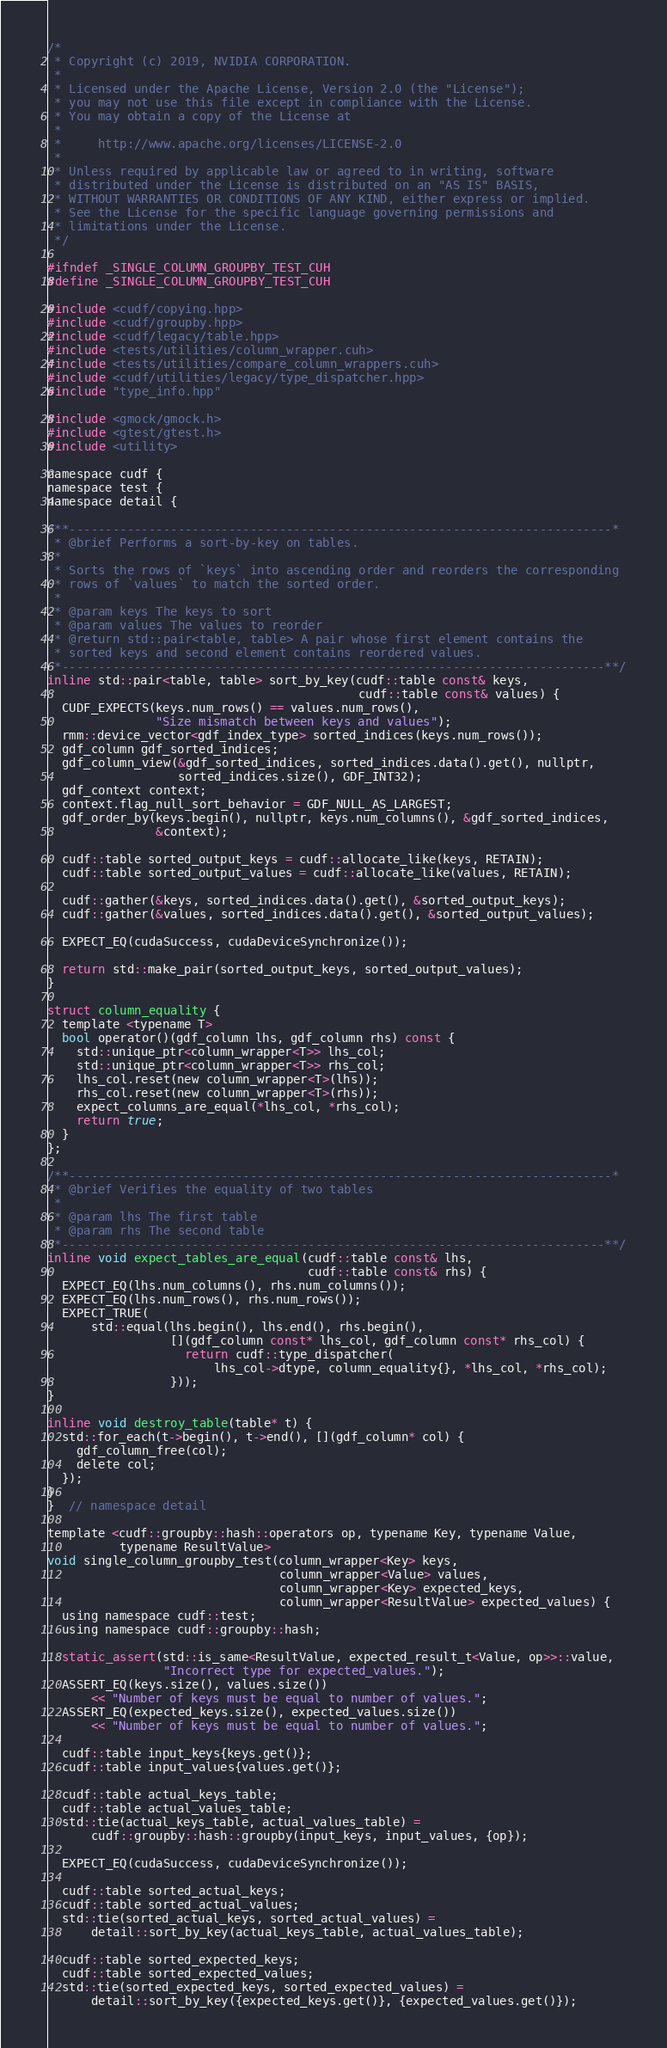Convert code to text. <code><loc_0><loc_0><loc_500><loc_500><_Cuda_>/*
 * Copyright (c) 2019, NVIDIA CORPORATION.
 *
 * Licensed under the Apache License, Version 2.0 (the "License");
 * you may not use this file except in compliance with the License.
 * You may obtain a copy of the License at
 *
 *     http://www.apache.org/licenses/LICENSE-2.0
 *
 * Unless required by applicable law or agreed to in writing, software
 * distributed under the License is distributed on an "AS IS" BASIS,
 * WITHOUT WARRANTIES OR CONDITIONS OF ANY KIND, either express or implied.
 * See the License for the specific language governing permissions and
 * limitations under the License.
 */

#ifndef _SINGLE_COLUMN_GROUPBY_TEST_CUH
#define _SINGLE_COLUMN_GROUPBY_TEST_CUH

#include <cudf/copying.hpp>
#include <cudf/groupby.hpp>
#include <cudf/legacy/table.hpp>
#include <tests/utilities/column_wrapper.cuh>
#include <tests/utilities/compare_column_wrappers.cuh>
#include <cudf/utilities/legacy/type_dispatcher.hpp>
#include "type_info.hpp"

#include <gmock/gmock.h>
#include <gtest/gtest.h>
#include <utility>

namespace cudf {
namespace test {
namespace detail {

/**---------------------------------------------------------------------------*
 * @brief Performs a sort-by-key on tables.
 *
 * Sorts the rows of `keys` into ascending order and reorders the corresponding
 * rows of `values` to match the sorted order.
 *
 * @param keys The keys to sort
 * @param values The values to reorder
 * @return std::pair<table, table> A pair whose first element contains the
 * sorted keys and second element contains reordered values.
 *---------------------------------------------------------------------------**/
inline std::pair<table, table> sort_by_key(cudf::table const& keys,
                                           cudf::table const& values) {
  CUDF_EXPECTS(keys.num_rows() == values.num_rows(),
               "Size mismatch between keys and values");
  rmm::device_vector<gdf_index_type> sorted_indices(keys.num_rows());
  gdf_column gdf_sorted_indices;
  gdf_column_view(&gdf_sorted_indices, sorted_indices.data().get(), nullptr,
                  sorted_indices.size(), GDF_INT32);
  gdf_context context;
  context.flag_null_sort_behavior = GDF_NULL_AS_LARGEST;
  gdf_order_by(keys.begin(), nullptr, keys.num_columns(), &gdf_sorted_indices,
               &context);

  cudf::table sorted_output_keys = cudf::allocate_like(keys, RETAIN);
  cudf::table sorted_output_values = cudf::allocate_like(values, RETAIN);

  cudf::gather(&keys, sorted_indices.data().get(), &sorted_output_keys);
  cudf::gather(&values, sorted_indices.data().get(), &sorted_output_values);

  EXPECT_EQ(cudaSuccess, cudaDeviceSynchronize());

  return std::make_pair(sorted_output_keys, sorted_output_values);
}

struct column_equality {
  template <typename T>
  bool operator()(gdf_column lhs, gdf_column rhs) const {
    std::unique_ptr<column_wrapper<T>> lhs_col;
    std::unique_ptr<column_wrapper<T>> rhs_col;
    lhs_col.reset(new column_wrapper<T>(lhs));
    rhs_col.reset(new column_wrapper<T>(rhs));
    expect_columns_are_equal(*lhs_col, *rhs_col);
    return true;
  }
};

/**---------------------------------------------------------------------------*
 * @brief Verifies the equality of two tables
 *
 * @param lhs The first table
 * @param rhs The second table
 *---------------------------------------------------------------------------**/
inline void expect_tables_are_equal(cudf::table const& lhs,
                                    cudf::table const& rhs) {
  EXPECT_EQ(lhs.num_columns(), rhs.num_columns());
  EXPECT_EQ(lhs.num_rows(), rhs.num_rows());
  EXPECT_TRUE(
      std::equal(lhs.begin(), lhs.end(), rhs.begin(),
                 [](gdf_column const* lhs_col, gdf_column const* rhs_col) {
                   return cudf::type_dispatcher(
                       lhs_col->dtype, column_equality{}, *lhs_col, *rhs_col);
                 }));
}

inline void destroy_table(table* t) {
  std::for_each(t->begin(), t->end(), [](gdf_column* col) {
    gdf_column_free(col);
    delete col;
  });
}
}  // namespace detail

template <cudf::groupby::hash::operators op, typename Key, typename Value,
          typename ResultValue>
void single_column_groupby_test(column_wrapper<Key> keys,
                                column_wrapper<Value> values,
                                column_wrapper<Key> expected_keys,
                                column_wrapper<ResultValue> expected_values) {
  using namespace cudf::test;
  using namespace cudf::groupby::hash;

  static_assert(std::is_same<ResultValue, expected_result_t<Value, op>>::value,
                "Incorrect type for expected_values.");
  ASSERT_EQ(keys.size(), values.size())
      << "Number of keys must be equal to number of values.";
  ASSERT_EQ(expected_keys.size(), expected_values.size())
      << "Number of keys must be equal to number of values.";

  cudf::table input_keys{keys.get()};
  cudf::table input_values{values.get()};

  cudf::table actual_keys_table;
  cudf::table actual_values_table;
  std::tie(actual_keys_table, actual_values_table) =
      cudf::groupby::hash::groupby(input_keys, input_values, {op});

  EXPECT_EQ(cudaSuccess, cudaDeviceSynchronize());

  cudf::table sorted_actual_keys;
  cudf::table sorted_actual_values;
  std::tie(sorted_actual_keys, sorted_actual_values) =
      detail::sort_by_key(actual_keys_table, actual_values_table);

  cudf::table sorted_expected_keys;
  cudf::table sorted_expected_values;
  std::tie(sorted_expected_keys, sorted_expected_values) =
      detail::sort_by_key({expected_keys.get()}, {expected_values.get()});
</code> 